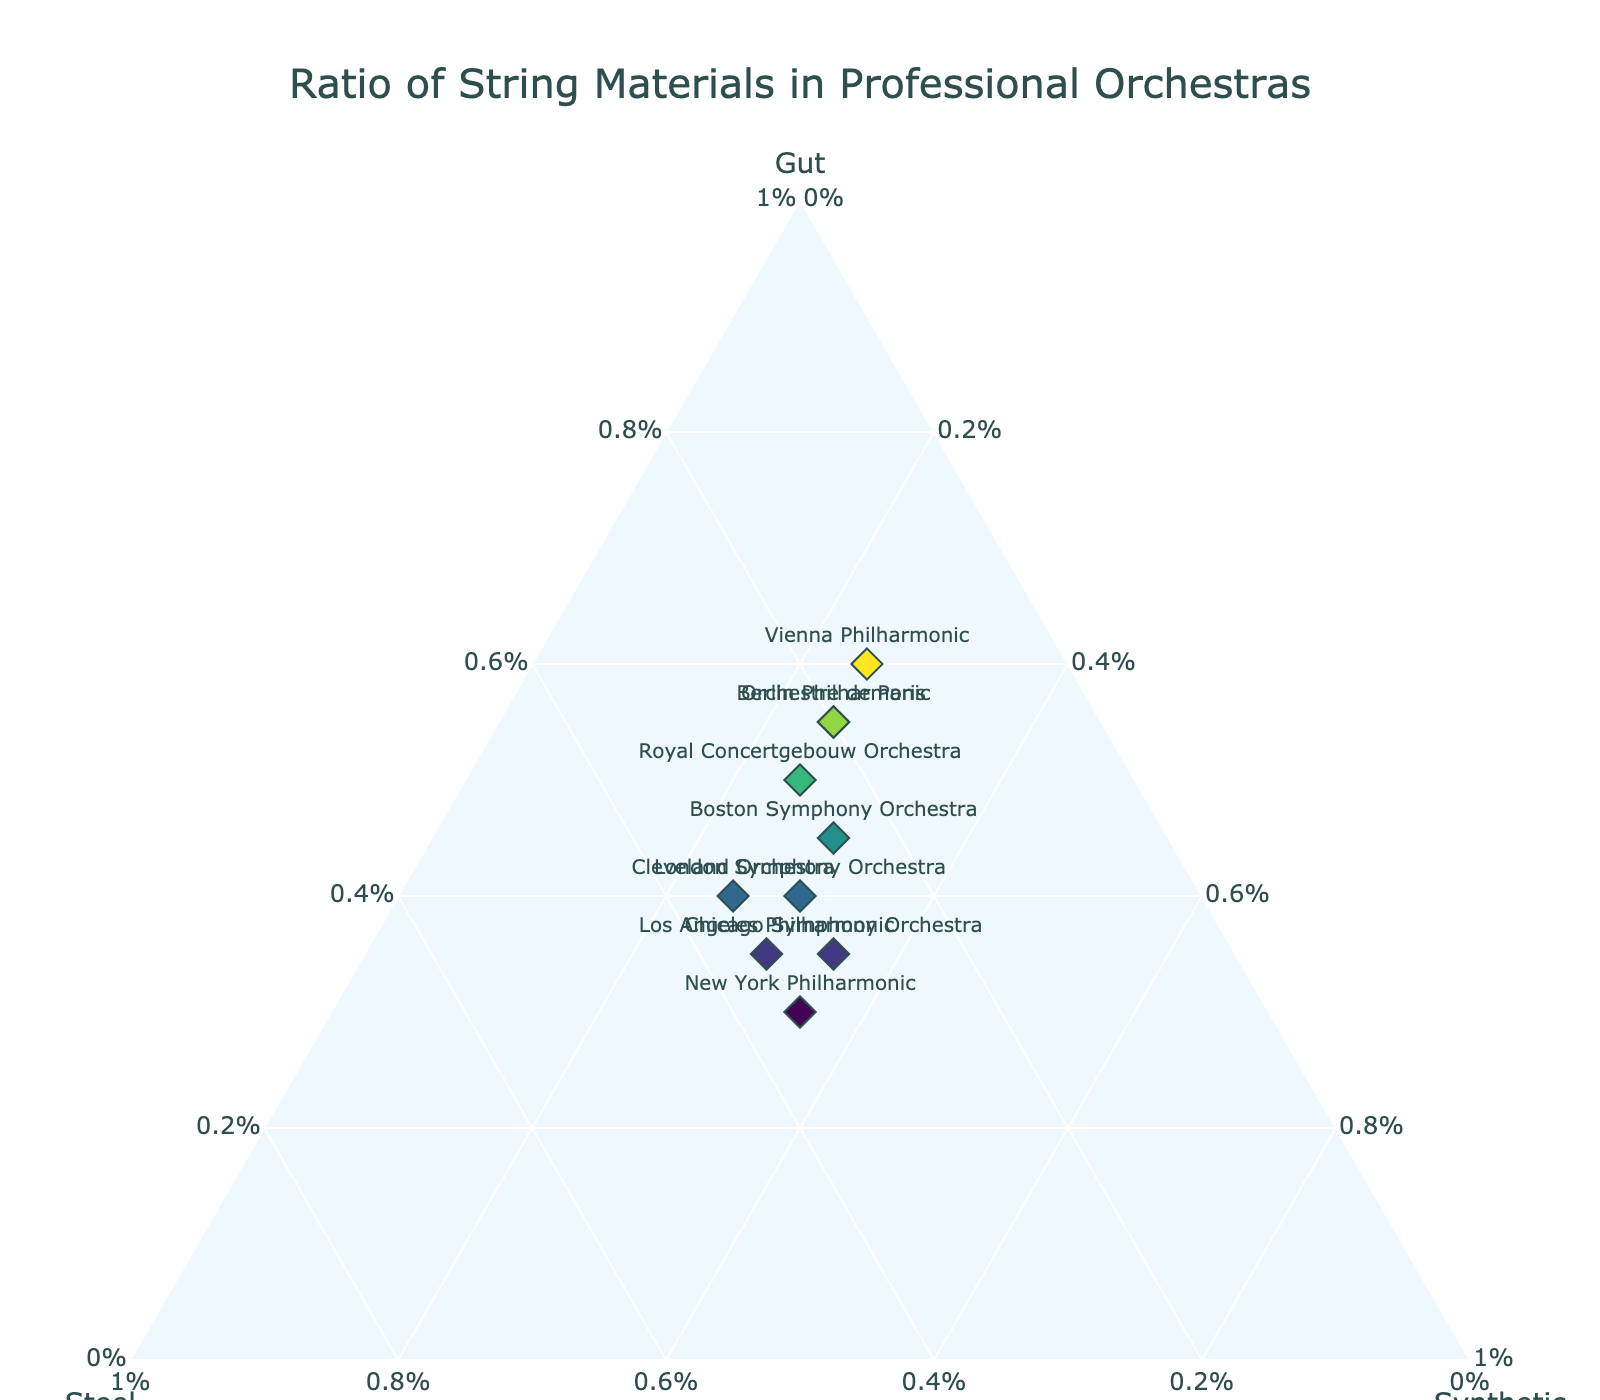What's the title of the figure? The title is located at the top center of the figure and describes the overall content being visualized.
Answer: Ratio of String Materials in Professional Orchestras How many orchestras have a higher proportion of gut strings than synthetic strings? For each orchestra, compare the values of gut and synthetic strings. Count the number of orchestras where the gut value is greater than the synthetic value.
Answer: 6 Which orchestra uses the highest proportion of steel strings? Look for the orchestra with the highest value on the steel axis.
Answer: New York Philharmonic What is the total proportion of synthetic strings used by the Berlin Philharmonic and Orchestre de Paris combined? Add the synthetic values for both orchestras: 0.25 (Berlin Philharmonic) + 0.25 (Orchestre de Paris).
Answer: 0.50 Do more orchestras have equal proportions of steel and synthetic strings or equal proportions of gut and steel strings? Count the number of orchestras with equal steel and synthetic proportions and compare it with the number of orchestras with equal gut and steel proportions.
Answer: Equal steel and synthetic If the Royal Concertgebouw Orchestra and Boston Symphony Orchestra were to combine their gut strings, what would their combined proportion be? Add the gut values of the Royal Concertgebouw Orchestra and Boston Symphony Orchestra: 0.50 + 0.45.
Answer: 0.95 Which orchestra has the lowest combined proportion of steel and synthetic strings? Calculate the sum of steel and synthetic values for each orchestra and identify the one with the lowest sum.
Answer: Vienna Philharmonic How does the proportion of gut strings in the Vienna Philharmonic compare to that of the London Symphony Orchestra? Compare the gut string values directly for both Vienna Philharmonic and London Symphony Orchestra (0.60 vs. 0.40).
Answer: Vienna Philharmonic has a higher proportion What's the proportion of gut strings in the orchestra that uses 35% steel strings? Identify the orchestra with 35% steel strings and find its gut proportion.
Answer: 0.30 (New York Philharmonic) What is the average proportion of synthetic strings used across all orchestras? Sum the synthetic string proportions of all orchestras and divide by the number of orchestras. (0.25 + 0.30 + 0.25 + 0.35 + 0.35 + 0.25 + 0.30 + 0.25 + 0.30 + 0.25) / 10
Answer: 0.29 